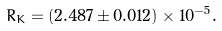Convert formula to latex. <formula><loc_0><loc_0><loc_500><loc_500>R _ { K } = ( 2 . 4 8 7 \pm 0 . 0 1 2 ) \times 1 0 ^ { - 5 } .</formula> 